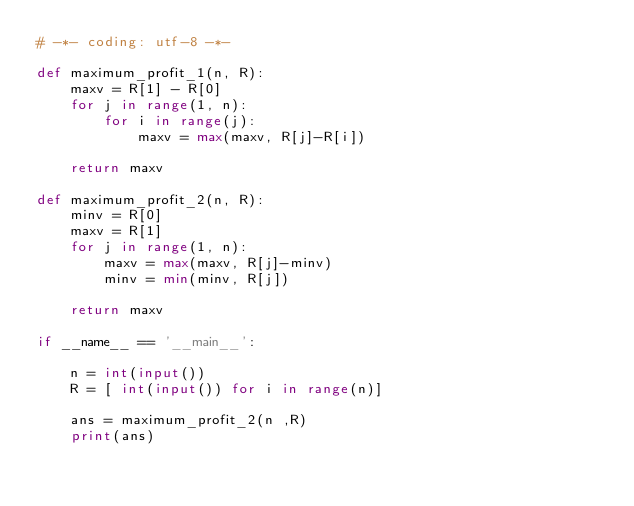<code> <loc_0><loc_0><loc_500><loc_500><_Python_># -*- coding: utf-8 -*-

def maximum_profit_1(n, R):
    maxv = R[1] - R[0]
    for j in range(1, n):
        for i in range(j):
            maxv = max(maxv, R[j]-R[i])

    return maxv

def maximum_profit_2(n, R):
    minv = R[0]
    maxv = R[1]
    for j in range(1, n):
        maxv = max(maxv, R[j]-minv)
        minv = min(minv, R[j])

    return maxv

if __name__ == '__main__':

    n = int(input())
    R = [ int(input()) for i in range(n)]

    ans = maximum_profit_2(n ,R)
    print(ans)
</code> 